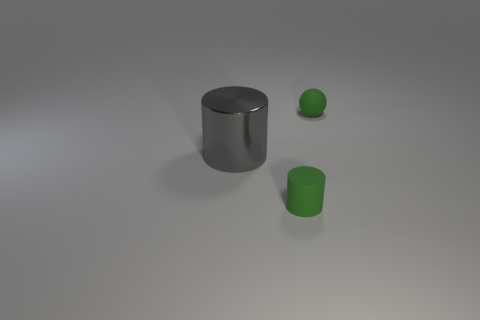Are there any matte cylinders that have the same color as the matte sphere?
Give a very brief answer. Yes. What is the color of the cylinder that is the same size as the green ball?
Your response must be concise. Green. What number of small objects are either gray cylinders or blue matte spheres?
Offer a terse response. 0. Are there the same number of tiny green rubber balls that are to the left of the green rubber cylinder and green cylinders on the right side of the gray object?
Provide a short and direct response. No. How many other green spheres are the same size as the green ball?
Keep it short and to the point. 0. How many gray objects are either tiny matte spheres or big metal cylinders?
Your answer should be compact. 1. Are there the same number of cylinders that are right of the rubber cylinder and big red cylinders?
Give a very brief answer. Yes. There is a gray object on the left side of the tiny green rubber sphere; what is its size?
Provide a succinct answer. Large. How many other things have the same shape as the gray shiny thing?
Your answer should be very brief. 1. What is the material of the object that is behind the small matte cylinder and in front of the matte sphere?
Your answer should be very brief. Metal. 